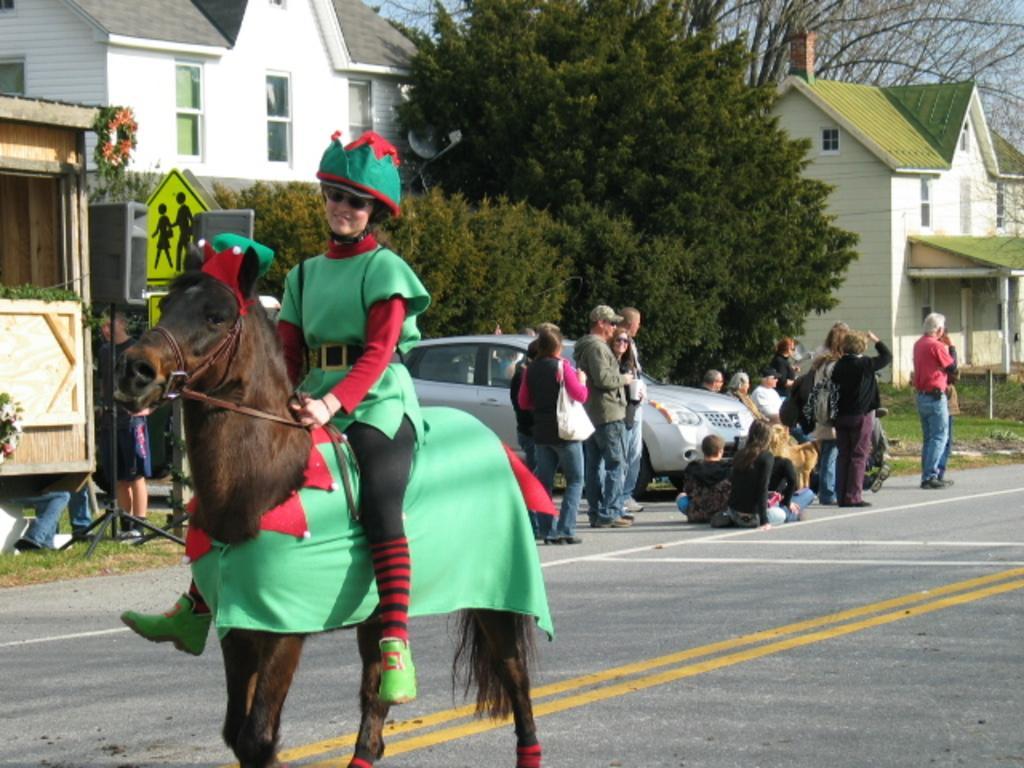Can you describe this image briefly? In front of the image there is a woman riding a horse on the road, behind the woman there are a few people sitting and standing on the road, behind them there are cars, sign boards, trees and buildings. 